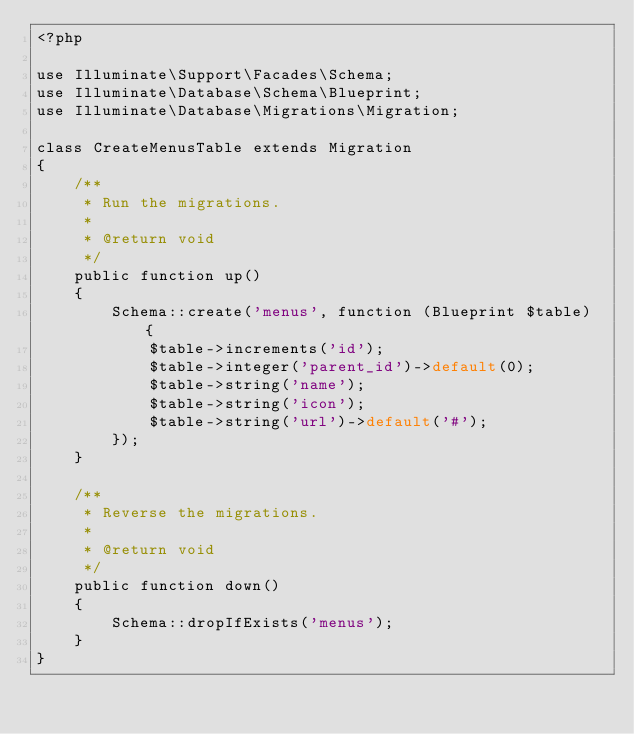Convert code to text. <code><loc_0><loc_0><loc_500><loc_500><_PHP_><?php

use Illuminate\Support\Facades\Schema;
use Illuminate\Database\Schema\Blueprint;
use Illuminate\Database\Migrations\Migration;

class CreateMenusTable extends Migration
{
    /**
     * Run the migrations.
     *
     * @return void
     */
    public function up()
    {
        Schema::create('menus', function (Blueprint $table) {
            $table->increments('id');
            $table->integer('parent_id')->default(0);
            $table->string('name');
            $table->string('icon');
            $table->string('url')->default('#');
        });
    }

    /**
     * Reverse the migrations.
     *
     * @return void
     */
    public function down()
    {
        Schema::dropIfExists('menus');
    }
}
</code> 